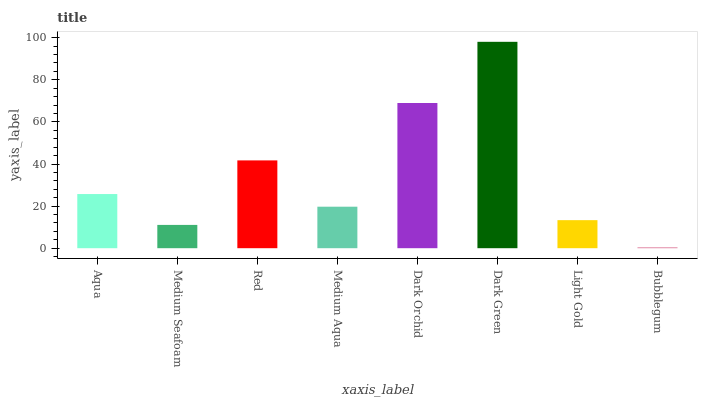Is Medium Seafoam the minimum?
Answer yes or no. No. Is Medium Seafoam the maximum?
Answer yes or no. No. Is Aqua greater than Medium Seafoam?
Answer yes or no. Yes. Is Medium Seafoam less than Aqua?
Answer yes or no. Yes. Is Medium Seafoam greater than Aqua?
Answer yes or no. No. Is Aqua less than Medium Seafoam?
Answer yes or no. No. Is Aqua the high median?
Answer yes or no. Yes. Is Medium Aqua the low median?
Answer yes or no. Yes. Is Dark Orchid the high median?
Answer yes or no. No. Is Bubblegum the low median?
Answer yes or no. No. 